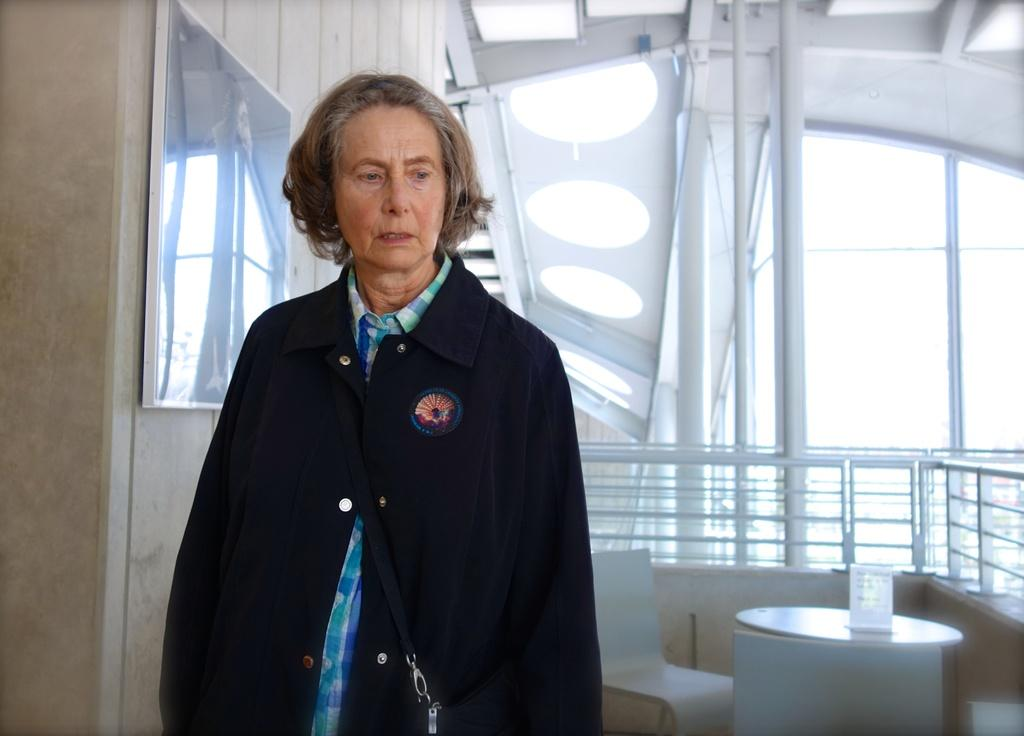Who is present in the image? There is a woman in the image. What is the woman doing in the image? The woman is standing in the image. What object can be seen on the table in the image? There is a menu card on the table in the image. What is the woman wearing in the image? The woman is wearing a black jacket in the image. What type of surprise can be seen on the woman's face in the image? There is no indication of a surprise or any particular facial expression on the woman's face in the image. 